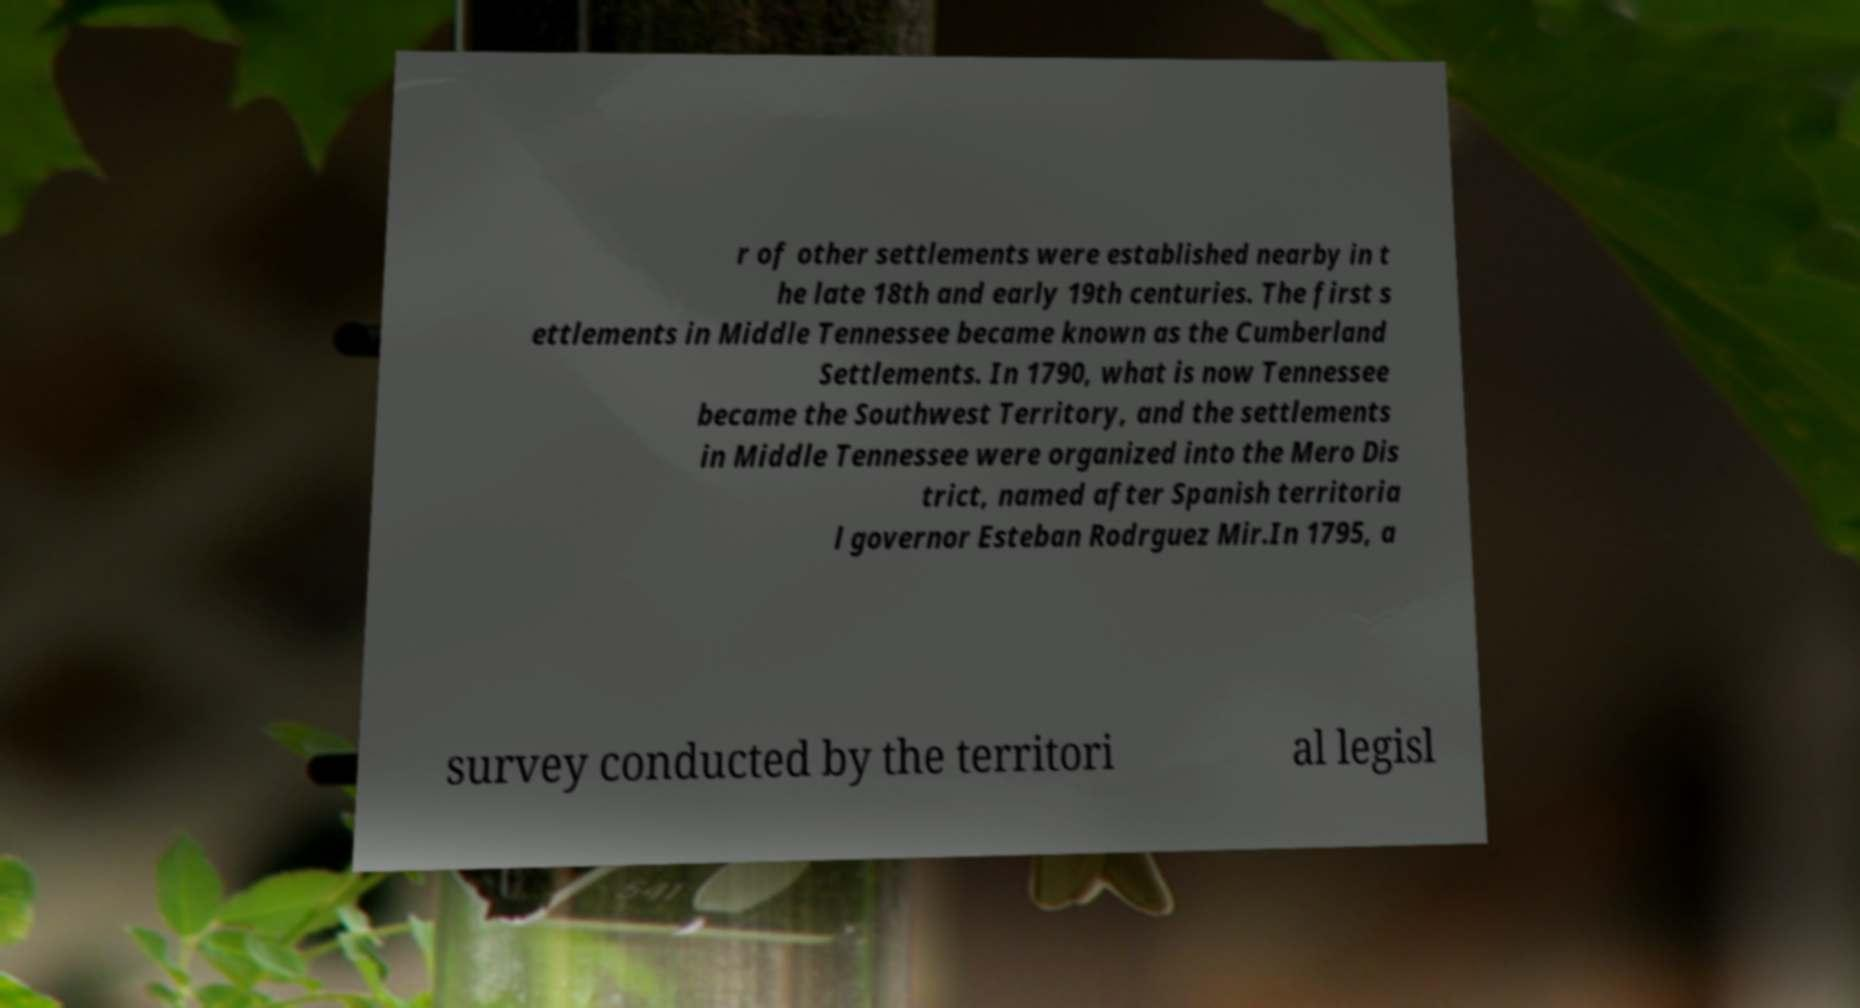I need the written content from this picture converted into text. Can you do that? r of other settlements were established nearby in t he late 18th and early 19th centuries. The first s ettlements in Middle Tennessee became known as the Cumberland Settlements. In 1790, what is now Tennessee became the Southwest Territory, and the settlements in Middle Tennessee were organized into the Mero Dis trict, named after Spanish territoria l governor Esteban Rodrguez Mir.In 1795, a survey conducted by the territori al legisl 